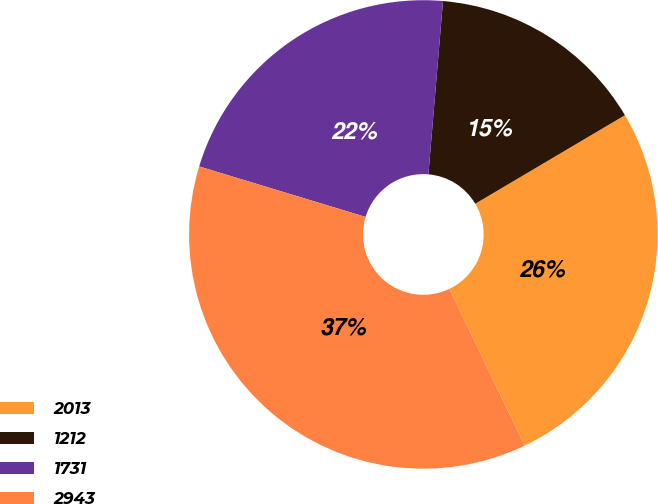Convert chart. <chart><loc_0><loc_0><loc_500><loc_500><pie_chart><fcel>2013<fcel>1212<fcel>1731<fcel>2943<nl><fcel>26.38%<fcel>15.16%<fcel>21.65%<fcel>36.81%<nl></chart> 